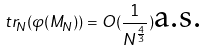Convert formula to latex. <formula><loc_0><loc_0><loc_500><loc_500>\ t r _ { N } ( \varphi ( M _ { N } ) ) = O ( \frac { 1 } { N ^ { \frac { 4 } { 3 } } } ) \text {a.s.}</formula> 